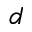Convert formula to latex. <formula><loc_0><loc_0><loc_500><loc_500>d</formula> 